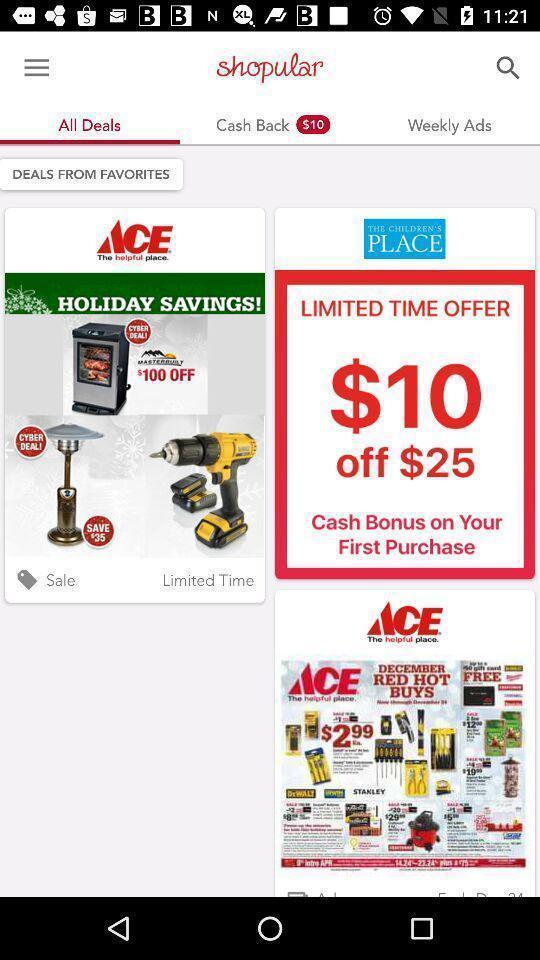Tell me about the visual elements in this screen capture. Page showing deals at top stores. 